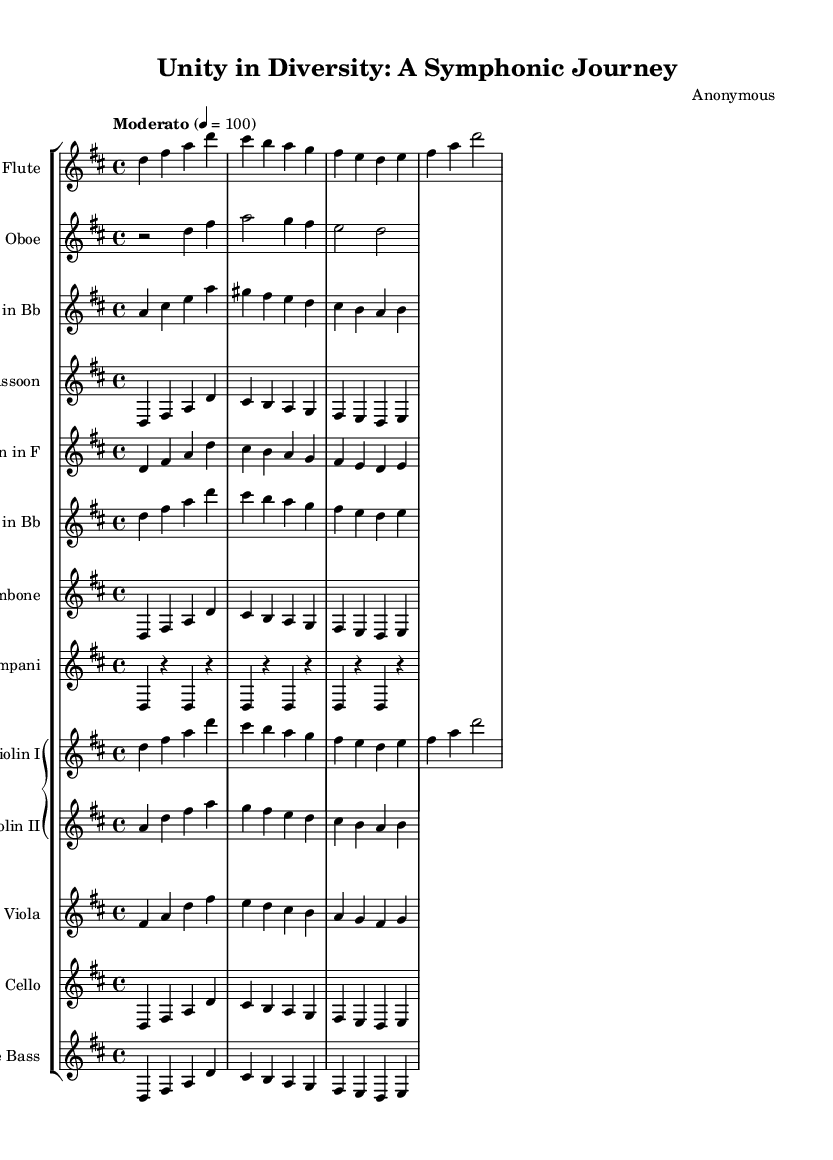What is the key signature of this music? The key signature is D major, which features two sharps (F# and C#). This can be determined by looking at the number of sharps noted in the key signature at the beginning of the score.
Answer: D major What is the time signature of this composition? The time signature is 4/4, as indicated at the beginning of the score. This means there are four beats in each measure, and the quarter note gets one beat.
Answer: 4/4 What is the tempo marking of the symphony? The tempo marking is "Moderato", which is stated at the top of the score. This indicates a moderate speed for the piece, typically around 100 beats per minute.
Answer: Moderato How many instruments are present in this symphony? There are 13 instruments listed in the score, each represented by a separate staff in the score. This count includes woodwinds, brass, strings, and timpani.
Answer: 13 Which instrument plays in the key of B flat? The instruments that play in the key of B flat are the Clarinet and Trumpet, as indicated by the transposition mentioned in their respective parts. This means they read notes that are a whole step lower than the written note.
Answer: Clarinet, Trumpet What is the primary theme of the symphony as reflected in the music? The primary theme is represented by the melodic lines that often rise and fall, symbolizing unity and diversity. This thematic material appears in the flute and strings, creating a sense of motion and dialogue among them.
Answer: Unity and diversity theme Which instruments are playing in unison during the first phrase? Flute, Oboe, Clarinet, Bassoon, Horn, Trumpet, Trombone, Violin I, and Cello are playing in unison during the first phrase as they share the same melodic line. This establishes a strong and cohesive start to the symphony.
Answer: Flute, Oboe, Clarinet, Bassoon, Horn, Trumpet, Trombone, Violin I, Cello 